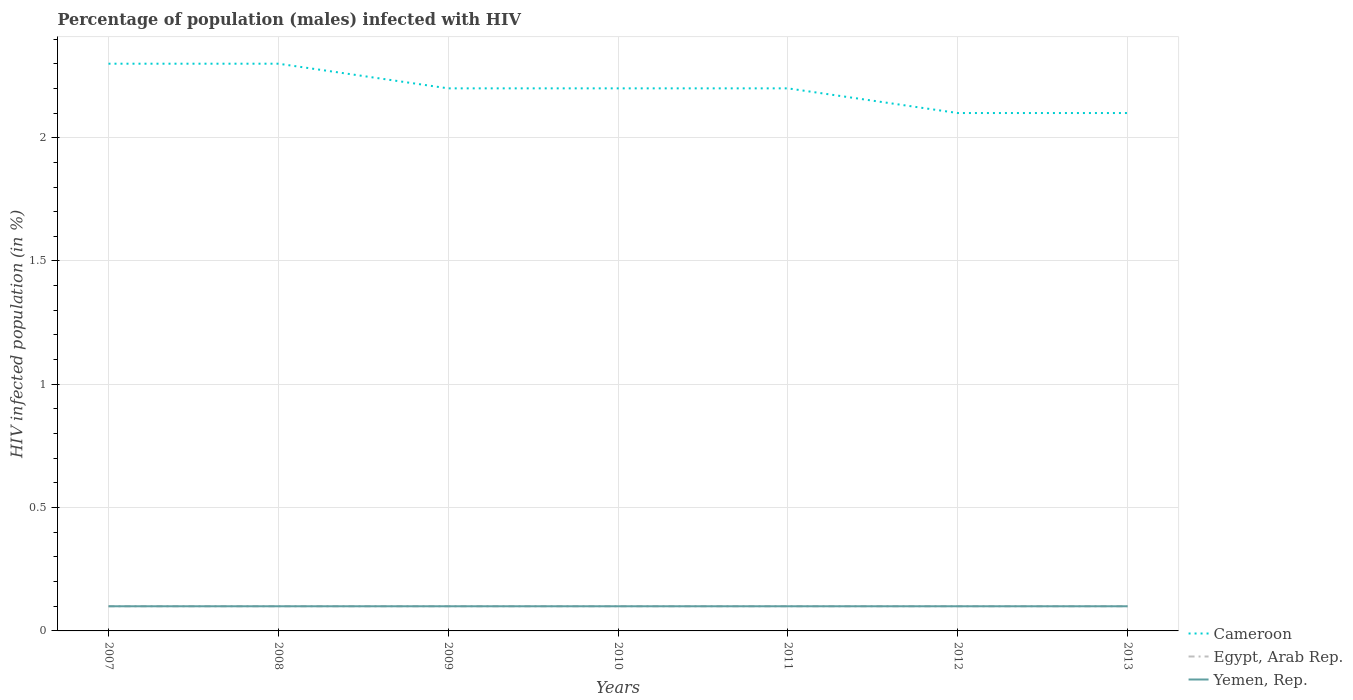What is the total percentage of HIV infected male population in Yemen, Rep. in the graph?
Offer a very short reply. 0. What is the difference between the highest and the second highest percentage of HIV infected male population in Yemen, Rep.?
Make the answer very short. 0. What is the difference between two consecutive major ticks on the Y-axis?
Make the answer very short. 0.5. Does the graph contain any zero values?
Keep it short and to the point. No. Where does the legend appear in the graph?
Provide a short and direct response. Bottom right. What is the title of the graph?
Provide a short and direct response. Percentage of population (males) infected with HIV. Does "High income: OECD" appear as one of the legend labels in the graph?
Provide a succinct answer. No. What is the label or title of the Y-axis?
Ensure brevity in your answer.  HIV infected population (in %). What is the HIV infected population (in %) of Cameroon in 2007?
Keep it short and to the point. 2.3. What is the HIV infected population (in %) in Egypt, Arab Rep. in 2007?
Offer a terse response. 0.1. What is the HIV infected population (in %) of Cameroon in 2008?
Make the answer very short. 2.3. What is the HIV infected population (in %) of Cameroon in 2009?
Provide a short and direct response. 2.2. What is the HIV infected population (in %) in Egypt, Arab Rep. in 2009?
Make the answer very short. 0.1. What is the HIV infected population (in %) in Yemen, Rep. in 2009?
Your answer should be compact. 0.1. What is the HIV infected population (in %) in Cameroon in 2010?
Your response must be concise. 2.2. What is the HIV infected population (in %) in Egypt, Arab Rep. in 2010?
Give a very brief answer. 0.1. What is the HIV infected population (in %) of Yemen, Rep. in 2010?
Provide a succinct answer. 0.1. What is the HIV infected population (in %) of Cameroon in 2011?
Your answer should be compact. 2.2. What is the HIV infected population (in %) of Egypt, Arab Rep. in 2011?
Your answer should be compact. 0.1. What is the HIV infected population (in %) in Cameroon in 2012?
Ensure brevity in your answer.  2.1. What is the HIV infected population (in %) of Egypt, Arab Rep. in 2012?
Provide a short and direct response. 0.1. What is the HIV infected population (in %) in Cameroon in 2013?
Your response must be concise. 2.1. What is the HIV infected population (in %) of Yemen, Rep. in 2013?
Your answer should be very brief. 0.1. Across all years, what is the maximum HIV infected population (in %) in Egypt, Arab Rep.?
Your answer should be very brief. 0.1. Across all years, what is the minimum HIV infected population (in %) in Egypt, Arab Rep.?
Your answer should be compact. 0.1. Across all years, what is the minimum HIV infected population (in %) in Yemen, Rep.?
Offer a terse response. 0.1. What is the total HIV infected population (in %) of Egypt, Arab Rep. in the graph?
Keep it short and to the point. 0.7. What is the difference between the HIV infected population (in %) of Cameroon in 2007 and that in 2009?
Keep it short and to the point. 0.1. What is the difference between the HIV infected population (in %) of Egypt, Arab Rep. in 2007 and that in 2009?
Make the answer very short. 0. What is the difference between the HIV infected population (in %) in Cameroon in 2007 and that in 2010?
Provide a short and direct response. 0.1. What is the difference between the HIV infected population (in %) of Cameroon in 2007 and that in 2012?
Offer a very short reply. 0.2. What is the difference between the HIV infected population (in %) in Cameroon in 2007 and that in 2013?
Make the answer very short. 0.2. What is the difference between the HIV infected population (in %) in Cameroon in 2008 and that in 2009?
Keep it short and to the point. 0.1. What is the difference between the HIV infected population (in %) of Egypt, Arab Rep. in 2008 and that in 2009?
Keep it short and to the point. 0. What is the difference between the HIV infected population (in %) of Cameroon in 2008 and that in 2010?
Offer a very short reply. 0.1. What is the difference between the HIV infected population (in %) in Yemen, Rep. in 2008 and that in 2010?
Provide a short and direct response. 0. What is the difference between the HIV infected population (in %) of Egypt, Arab Rep. in 2008 and that in 2011?
Provide a succinct answer. 0. What is the difference between the HIV infected population (in %) in Yemen, Rep. in 2008 and that in 2011?
Your answer should be compact. 0. What is the difference between the HIV infected population (in %) of Egypt, Arab Rep. in 2008 and that in 2012?
Your answer should be very brief. 0. What is the difference between the HIV infected population (in %) of Egypt, Arab Rep. in 2008 and that in 2013?
Ensure brevity in your answer.  0. What is the difference between the HIV infected population (in %) of Yemen, Rep. in 2008 and that in 2013?
Your answer should be compact. 0. What is the difference between the HIV infected population (in %) of Cameroon in 2009 and that in 2011?
Keep it short and to the point. 0. What is the difference between the HIV infected population (in %) in Egypt, Arab Rep. in 2009 and that in 2011?
Provide a short and direct response. 0. What is the difference between the HIV infected population (in %) of Yemen, Rep. in 2009 and that in 2011?
Provide a succinct answer. 0. What is the difference between the HIV infected population (in %) of Cameroon in 2009 and that in 2012?
Your answer should be very brief. 0.1. What is the difference between the HIV infected population (in %) of Cameroon in 2009 and that in 2013?
Offer a very short reply. 0.1. What is the difference between the HIV infected population (in %) of Yemen, Rep. in 2009 and that in 2013?
Offer a terse response. 0. What is the difference between the HIV infected population (in %) of Cameroon in 2010 and that in 2011?
Your response must be concise. 0. What is the difference between the HIV infected population (in %) of Egypt, Arab Rep. in 2010 and that in 2011?
Offer a very short reply. 0. What is the difference between the HIV infected population (in %) in Cameroon in 2010 and that in 2012?
Your response must be concise. 0.1. What is the difference between the HIV infected population (in %) of Egypt, Arab Rep. in 2010 and that in 2012?
Keep it short and to the point. 0. What is the difference between the HIV infected population (in %) of Cameroon in 2010 and that in 2013?
Your answer should be compact. 0.1. What is the difference between the HIV infected population (in %) in Egypt, Arab Rep. in 2010 and that in 2013?
Provide a short and direct response. 0. What is the difference between the HIV infected population (in %) in Yemen, Rep. in 2011 and that in 2012?
Keep it short and to the point. 0. What is the difference between the HIV infected population (in %) of Cameroon in 2011 and that in 2013?
Provide a succinct answer. 0.1. What is the difference between the HIV infected population (in %) in Egypt, Arab Rep. in 2011 and that in 2013?
Offer a very short reply. 0. What is the difference between the HIV infected population (in %) of Cameroon in 2012 and that in 2013?
Provide a short and direct response. 0. What is the difference between the HIV infected population (in %) of Cameroon in 2007 and the HIV infected population (in %) of Egypt, Arab Rep. in 2008?
Ensure brevity in your answer.  2.2. What is the difference between the HIV infected population (in %) of Cameroon in 2007 and the HIV infected population (in %) of Yemen, Rep. in 2009?
Provide a short and direct response. 2.2. What is the difference between the HIV infected population (in %) in Cameroon in 2007 and the HIV infected population (in %) in Yemen, Rep. in 2010?
Keep it short and to the point. 2.2. What is the difference between the HIV infected population (in %) of Cameroon in 2007 and the HIV infected population (in %) of Egypt, Arab Rep. in 2011?
Keep it short and to the point. 2.2. What is the difference between the HIV infected population (in %) of Egypt, Arab Rep. in 2007 and the HIV infected population (in %) of Yemen, Rep. in 2011?
Your response must be concise. 0. What is the difference between the HIV infected population (in %) in Cameroon in 2007 and the HIV infected population (in %) in Egypt, Arab Rep. in 2013?
Make the answer very short. 2.2. What is the difference between the HIV infected population (in %) in Cameroon in 2008 and the HIV infected population (in %) in Yemen, Rep. in 2009?
Your answer should be compact. 2.2. What is the difference between the HIV infected population (in %) of Egypt, Arab Rep. in 2008 and the HIV infected population (in %) of Yemen, Rep. in 2009?
Offer a terse response. 0. What is the difference between the HIV infected population (in %) in Cameroon in 2008 and the HIV infected population (in %) in Yemen, Rep. in 2010?
Make the answer very short. 2.2. What is the difference between the HIV infected population (in %) of Cameroon in 2008 and the HIV infected population (in %) of Egypt, Arab Rep. in 2011?
Offer a terse response. 2.2. What is the difference between the HIV infected population (in %) of Cameroon in 2008 and the HIV infected population (in %) of Egypt, Arab Rep. in 2012?
Offer a terse response. 2.2. What is the difference between the HIV infected population (in %) in Cameroon in 2008 and the HIV infected population (in %) in Yemen, Rep. in 2012?
Give a very brief answer. 2.2. What is the difference between the HIV infected population (in %) in Egypt, Arab Rep. in 2008 and the HIV infected population (in %) in Yemen, Rep. in 2013?
Offer a terse response. 0. What is the difference between the HIV infected population (in %) in Cameroon in 2009 and the HIV infected population (in %) in Egypt, Arab Rep. in 2010?
Give a very brief answer. 2.1. What is the difference between the HIV infected population (in %) of Egypt, Arab Rep. in 2009 and the HIV infected population (in %) of Yemen, Rep. in 2010?
Your response must be concise. 0. What is the difference between the HIV infected population (in %) of Cameroon in 2009 and the HIV infected population (in %) of Egypt, Arab Rep. in 2011?
Your answer should be very brief. 2.1. What is the difference between the HIV infected population (in %) of Cameroon in 2009 and the HIV infected population (in %) of Yemen, Rep. in 2011?
Make the answer very short. 2.1. What is the difference between the HIV infected population (in %) in Cameroon in 2009 and the HIV infected population (in %) in Egypt, Arab Rep. in 2012?
Keep it short and to the point. 2.1. What is the difference between the HIV infected population (in %) in Cameroon in 2009 and the HIV infected population (in %) in Yemen, Rep. in 2012?
Your answer should be very brief. 2.1. What is the difference between the HIV infected population (in %) of Cameroon in 2009 and the HIV infected population (in %) of Egypt, Arab Rep. in 2013?
Your answer should be compact. 2.1. What is the difference between the HIV infected population (in %) of Cameroon in 2009 and the HIV infected population (in %) of Yemen, Rep. in 2013?
Give a very brief answer. 2.1. What is the difference between the HIV infected population (in %) in Egypt, Arab Rep. in 2009 and the HIV infected population (in %) in Yemen, Rep. in 2013?
Keep it short and to the point. 0. What is the difference between the HIV infected population (in %) in Cameroon in 2010 and the HIV infected population (in %) in Yemen, Rep. in 2013?
Your response must be concise. 2.1. What is the difference between the HIV infected population (in %) in Egypt, Arab Rep. in 2010 and the HIV infected population (in %) in Yemen, Rep. in 2013?
Keep it short and to the point. 0. What is the difference between the HIV infected population (in %) in Cameroon in 2011 and the HIV infected population (in %) in Yemen, Rep. in 2012?
Your answer should be compact. 2.1. What is the difference between the HIV infected population (in %) of Egypt, Arab Rep. in 2011 and the HIV infected population (in %) of Yemen, Rep. in 2012?
Ensure brevity in your answer.  0. What is the difference between the HIV infected population (in %) in Cameroon in 2011 and the HIV infected population (in %) in Egypt, Arab Rep. in 2013?
Make the answer very short. 2.1. What is the average HIV infected population (in %) of Egypt, Arab Rep. per year?
Provide a short and direct response. 0.1. What is the average HIV infected population (in %) of Yemen, Rep. per year?
Provide a short and direct response. 0.1. In the year 2007, what is the difference between the HIV infected population (in %) in Cameroon and HIV infected population (in %) in Egypt, Arab Rep.?
Your answer should be compact. 2.2. In the year 2007, what is the difference between the HIV infected population (in %) of Cameroon and HIV infected population (in %) of Yemen, Rep.?
Your answer should be compact. 2.2. In the year 2008, what is the difference between the HIV infected population (in %) in Egypt, Arab Rep. and HIV infected population (in %) in Yemen, Rep.?
Give a very brief answer. 0. In the year 2009, what is the difference between the HIV infected population (in %) in Cameroon and HIV infected population (in %) in Yemen, Rep.?
Keep it short and to the point. 2.1. In the year 2009, what is the difference between the HIV infected population (in %) of Egypt, Arab Rep. and HIV infected population (in %) of Yemen, Rep.?
Your answer should be compact. 0. In the year 2010, what is the difference between the HIV infected population (in %) of Cameroon and HIV infected population (in %) of Egypt, Arab Rep.?
Provide a succinct answer. 2.1. In the year 2010, what is the difference between the HIV infected population (in %) of Cameroon and HIV infected population (in %) of Yemen, Rep.?
Offer a very short reply. 2.1. In the year 2010, what is the difference between the HIV infected population (in %) of Egypt, Arab Rep. and HIV infected population (in %) of Yemen, Rep.?
Your response must be concise. 0. In the year 2011, what is the difference between the HIV infected population (in %) in Cameroon and HIV infected population (in %) in Egypt, Arab Rep.?
Your response must be concise. 2.1. In the year 2011, what is the difference between the HIV infected population (in %) in Cameroon and HIV infected population (in %) in Yemen, Rep.?
Provide a short and direct response. 2.1. In the year 2012, what is the difference between the HIV infected population (in %) of Cameroon and HIV infected population (in %) of Yemen, Rep.?
Offer a very short reply. 2. In the year 2012, what is the difference between the HIV infected population (in %) of Egypt, Arab Rep. and HIV infected population (in %) of Yemen, Rep.?
Your answer should be very brief. 0. In the year 2013, what is the difference between the HIV infected population (in %) in Cameroon and HIV infected population (in %) in Egypt, Arab Rep.?
Provide a succinct answer. 2. In the year 2013, what is the difference between the HIV infected population (in %) of Cameroon and HIV infected population (in %) of Yemen, Rep.?
Provide a succinct answer. 2. In the year 2013, what is the difference between the HIV infected population (in %) of Egypt, Arab Rep. and HIV infected population (in %) of Yemen, Rep.?
Your answer should be very brief. 0. What is the ratio of the HIV infected population (in %) of Cameroon in 2007 to that in 2008?
Make the answer very short. 1. What is the ratio of the HIV infected population (in %) in Egypt, Arab Rep. in 2007 to that in 2008?
Offer a very short reply. 1. What is the ratio of the HIV infected population (in %) of Cameroon in 2007 to that in 2009?
Offer a very short reply. 1.05. What is the ratio of the HIV infected population (in %) of Egypt, Arab Rep. in 2007 to that in 2009?
Provide a short and direct response. 1. What is the ratio of the HIV infected population (in %) of Yemen, Rep. in 2007 to that in 2009?
Keep it short and to the point. 1. What is the ratio of the HIV infected population (in %) in Cameroon in 2007 to that in 2010?
Provide a succinct answer. 1.05. What is the ratio of the HIV infected population (in %) of Egypt, Arab Rep. in 2007 to that in 2010?
Offer a very short reply. 1. What is the ratio of the HIV infected population (in %) of Cameroon in 2007 to that in 2011?
Make the answer very short. 1.05. What is the ratio of the HIV infected population (in %) of Egypt, Arab Rep. in 2007 to that in 2011?
Give a very brief answer. 1. What is the ratio of the HIV infected population (in %) of Yemen, Rep. in 2007 to that in 2011?
Ensure brevity in your answer.  1. What is the ratio of the HIV infected population (in %) in Cameroon in 2007 to that in 2012?
Ensure brevity in your answer.  1.1. What is the ratio of the HIV infected population (in %) in Cameroon in 2007 to that in 2013?
Your response must be concise. 1.1. What is the ratio of the HIV infected population (in %) of Yemen, Rep. in 2007 to that in 2013?
Your answer should be compact. 1. What is the ratio of the HIV infected population (in %) in Cameroon in 2008 to that in 2009?
Your answer should be very brief. 1.05. What is the ratio of the HIV infected population (in %) in Yemen, Rep. in 2008 to that in 2009?
Provide a succinct answer. 1. What is the ratio of the HIV infected population (in %) in Cameroon in 2008 to that in 2010?
Your response must be concise. 1.05. What is the ratio of the HIV infected population (in %) of Cameroon in 2008 to that in 2011?
Give a very brief answer. 1.05. What is the ratio of the HIV infected population (in %) of Egypt, Arab Rep. in 2008 to that in 2011?
Make the answer very short. 1. What is the ratio of the HIV infected population (in %) in Yemen, Rep. in 2008 to that in 2011?
Your answer should be compact. 1. What is the ratio of the HIV infected population (in %) in Cameroon in 2008 to that in 2012?
Your answer should be compact. 1.1. What is the ratio of the HIV infected population (in %) in Egypt, Arab Rep. in 2008 to that in 2012?
Ensure brevity in your answer.  1. What is the ratio of the HIV infected population (in %) in Cameroon in 2008 to that in 2013?
Ensure brevity in your answer.  1.1. What is the ratio of the HIV infected population (in %) in Egypt, Arab Rep. in 2008 to that in 2013?
Your response must be concise. 1. What is the ratio of the HIV infected population (in %) in Yemen, Rep. in 2009 to that in 2011?
Your response must be concise. 1. What is the ratio of the HIV infected population (in %) of Cameroon in 2009 to that in 2012?
Provide a succinct answer. 1.05. What is the ratio of the HIV infected population (in %) of Cameroon in 2009 to that in 2013?
Give a very brief answer. 1.05. What is the ratio of the HIV infected population (in %) of Yemen, Rep. in 2009 to that in 2013?
Keep it short and to the point. 1. What is the ratio of the HIV infected population (in %) in Egypt, Arab Rep. in 2010 to that in 2011?
Keep it short and to the point. 1. What is the ratio of the HIV infected population (in %) in Yemen, Rep. in 2010 to that in 2011?
Your answer should be very brief. 1. What is the ratio of the HIV infected population (in %) in Cameroon in 2010 to that in 2012?
Offer a terse response. 1.05. What is the ratio of the HIV infected population (in %) of Yemen, Rep. in 2010 to that in 2012?
Ensure brevity in your answer.  1. What is the ratio of the HIV infected population (in %) in Cameroon in 2010 to that in 2013?
Ensure brevity in your answer.  1.05. What is the ratio of the HIV infected population (in %) of Egypt, Arab Rep. in 2010 to that in 2013?
Provide a succinct answer. 1. What is the ratio of the HIV infected population (in %) in Cameroon in 2011 to that in 2012?
Your answer should be compact. 1.05. What is the ratio of the HIV infected population (in %) of Egypt, Arab Rep. in 2011 to that in 2012?
Provide a short and direct response. 1. What is the ratio of the HIV infected population (in %) of Yemen, Rep. in 2011 to that in 2012?
Your response must be concise. 1. What is the ratio of the HIV infected population (in %) of Cameroon in 2011 to that in 2013?
Your response must be concise. 1.05. What is the ratio of the HIV infected population (in %) of Yemen, Rep. in 2011 to that in 2013?
Ensure brevity in your answer.  1. What is the ratio of the HIV infected population (in %) of Yemen, Rep. in 2012 to that in 2013?
Your answer should be very brief. 1. What is the difference between the highest and the second highest HIV infected population (in %) of Egypt, Arab Rep.?
Ensure brevity in your answer.  0. What is the difference between the highest and the lowest HIV infected population (in %) of Cameroon?
Keep it short and to the point. 0.2. What is the difference between the highest and the lowest HIV infected population (in %) in Egypt, Arab Rep.?
Offer a very short reply. 0. 